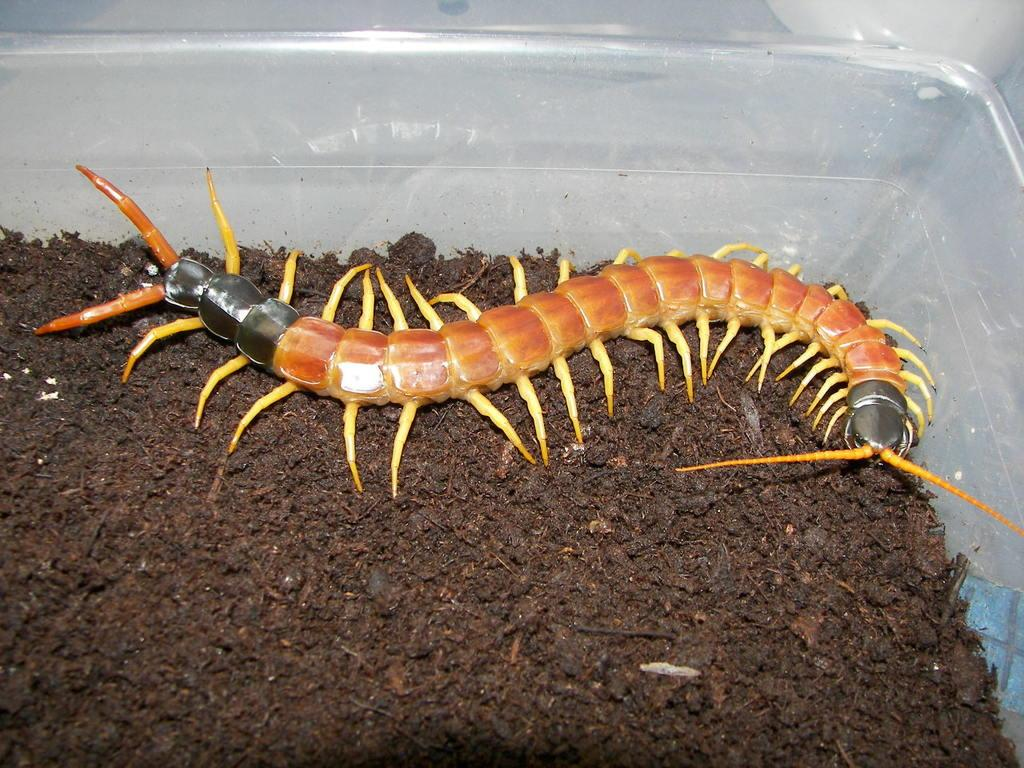What is present in the image? There is an insect in the image. What is the insect sitting on? The insect is on mud. How is the mud contained in the image? The mud is kept in a white color bowl. What type of ear is visible in the image? There is no ear present in the image; it features an insect on mud in a white bowl. 